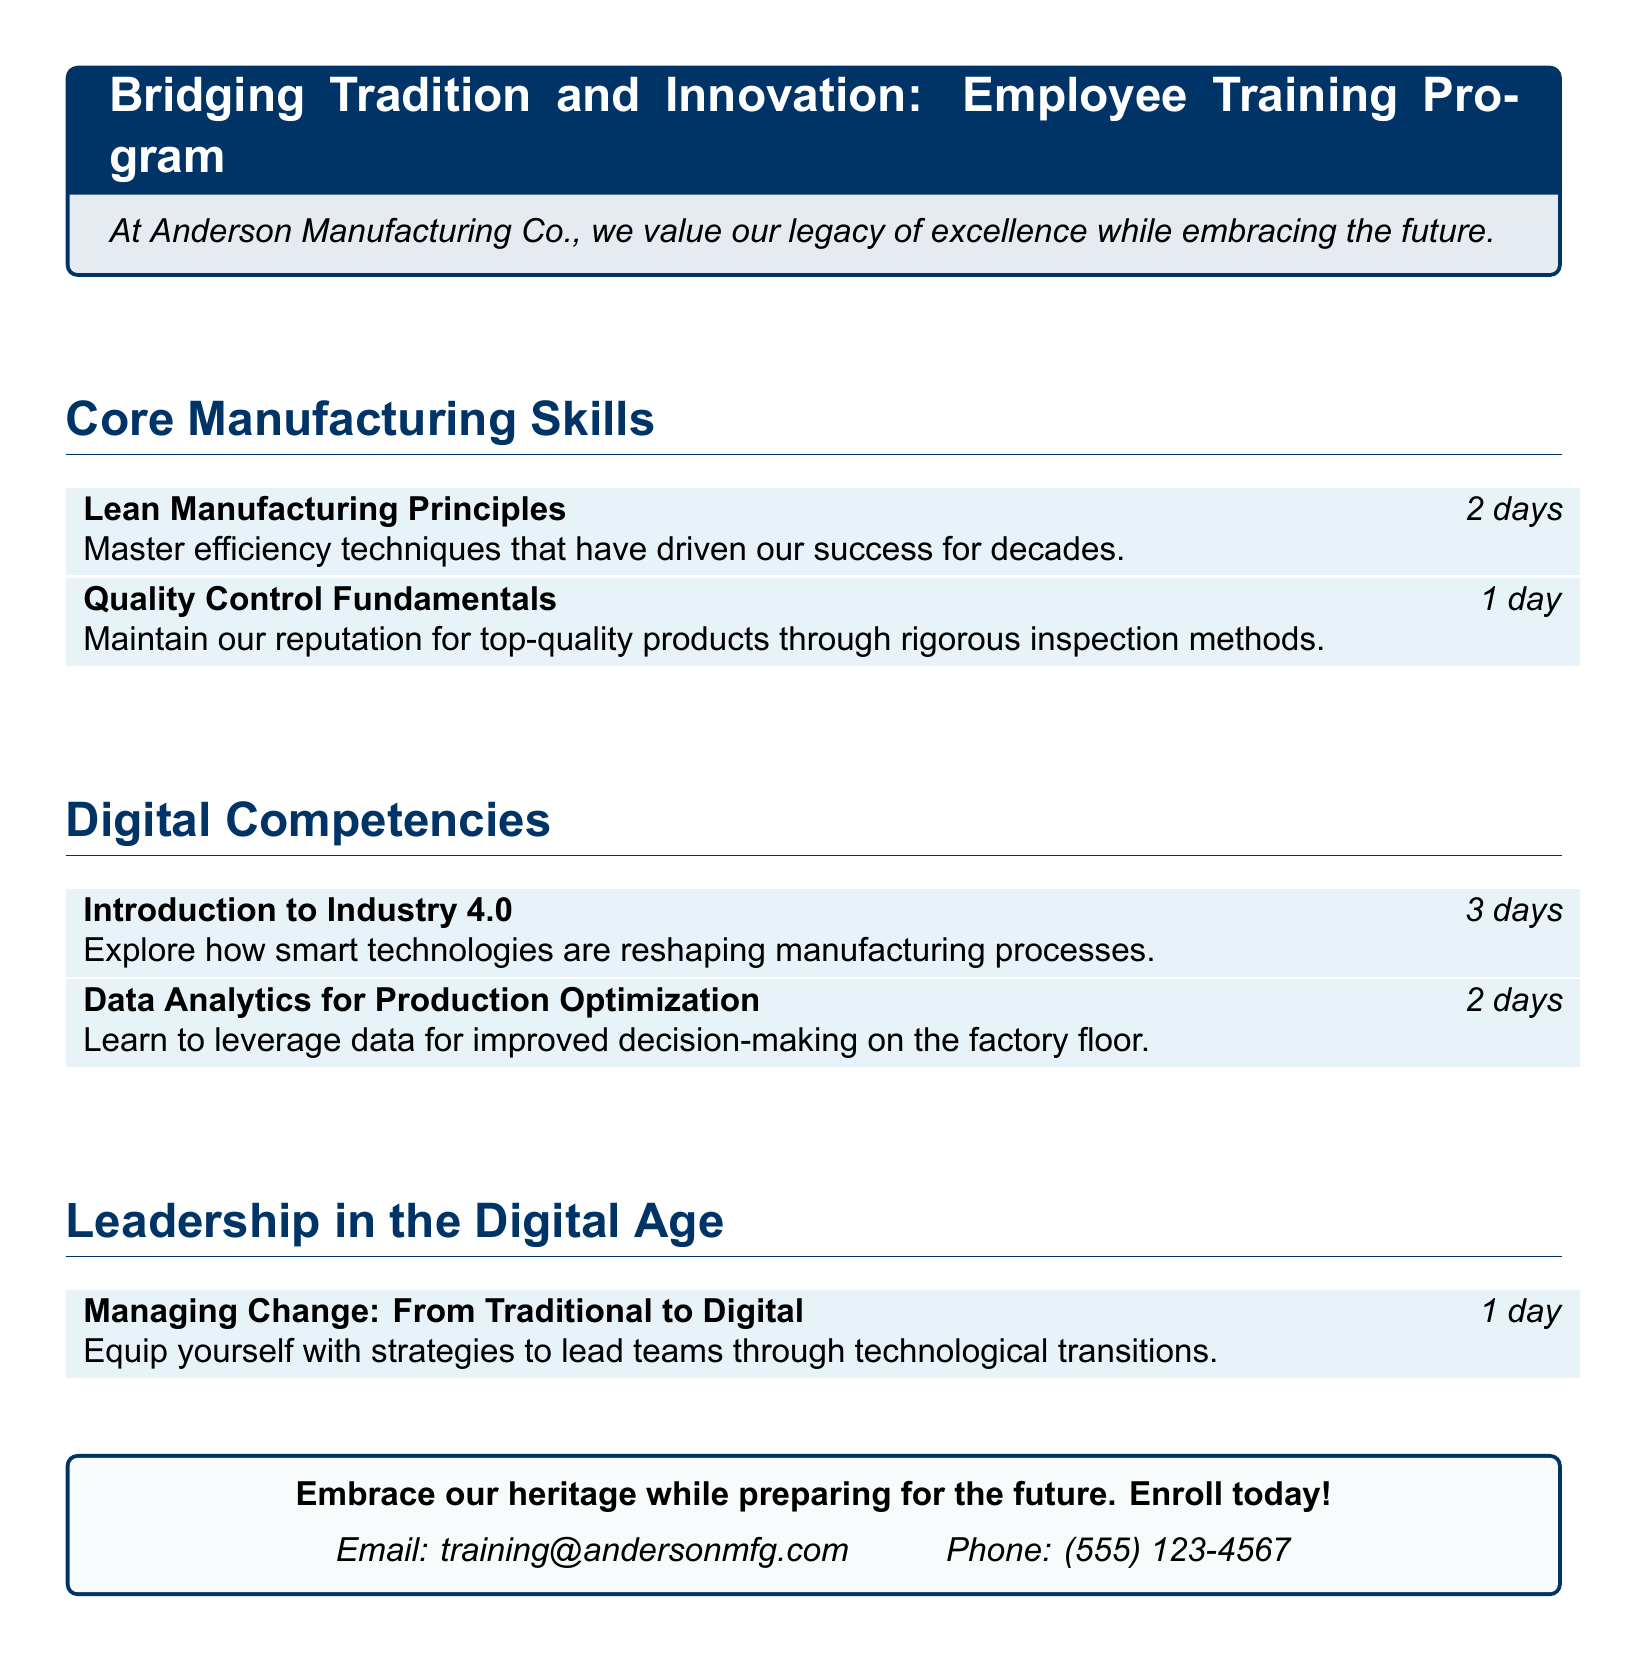What is the title of the training program? The title of the training program is prominently placed at the top, indicating the focus on both tradition and innovation.
Answer: Bridging Tradition and Innovation: Employee Training Program How many days is the "Introduction to Industry 4.0" course? The duration of the course is mentioned directly beside its title, indicating how long it will take to complete the course.
Answer: 3 days What is the focus of the "Data Analytics for Production Optimization" course? The course description provides insight into its content, focusing on the application of data in manufacturing.
Answer: Leverage data for improved decision-making How long does the "Managing Change: From Traditional to Digital" course last? The document specifies the duration of each course, including this leadership course aimed at navigating digital transitions.
Answer: 1 day Which color is used for the main title section? The color used for the title section is described as dark blue, influencing the visual appeal and theme of the document.
Answer: Dark blue What type of skills does the "Lean Manufacturing Principles" course emphasize? The course description highlights the focus on efficiency techniques critical to manufacturing success.
Answer: Efficiency techniques How can one enroll in the training program? The contact information for enrollment is provided at the end of the document, indicating how potential participants can get involved.
Answer: Email or phone What is the main theme of the employee training program? The overarching message of the training program is summarized in the introductory statement, reflecting a blend of past and future strategies.
Answer: Embrace our heritage while preparing for the future 